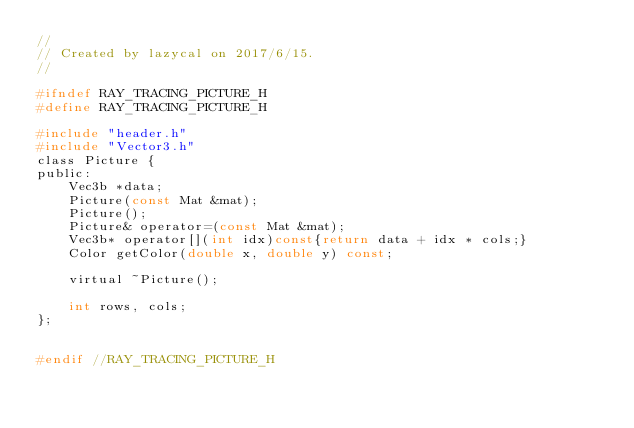<code> <loc_0><loc_0><loc_500><loc_500><_C_>//
// Created by lazycal on 2017/6/15.
//

#ifndef RAY_TRACING_PICTURE_H
#define RAY_TRACING_PICTURE_H

#include "header.h"
#include "Vector3.h"
class Picture {
public:
    Vec3b *data;
    Picture(const Mat &mat);
    Picture();
    Picture& operator=(const Mat &mat);
    Vec3b* operator[](int idx)const{return data + idx * cols;}
    Color getColor(double x, double y) const;

    virtual ~Picture();

    int rows, cols;
};


#endif //RAY_TRACING_PICTURE_H
</code> 